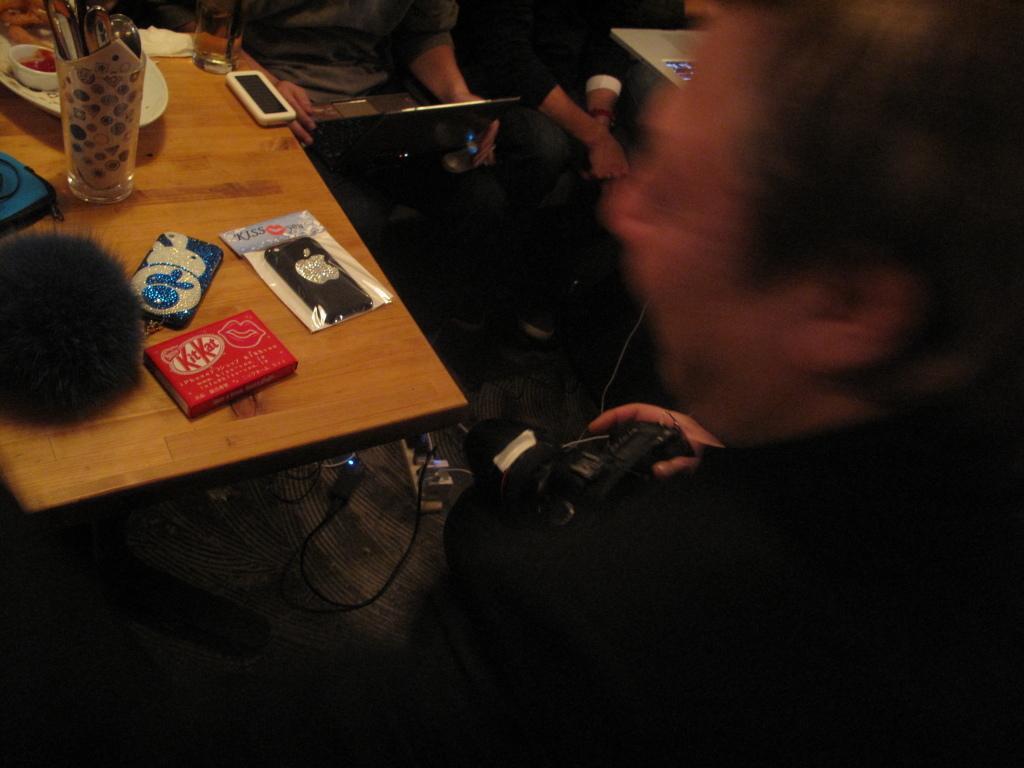Could you give a brief overview of what you see in this image? This picture shows few people seated and we see a man standing holding a camera in his hand and we see mobile pouches and mobile and few plates and a glass on the table 